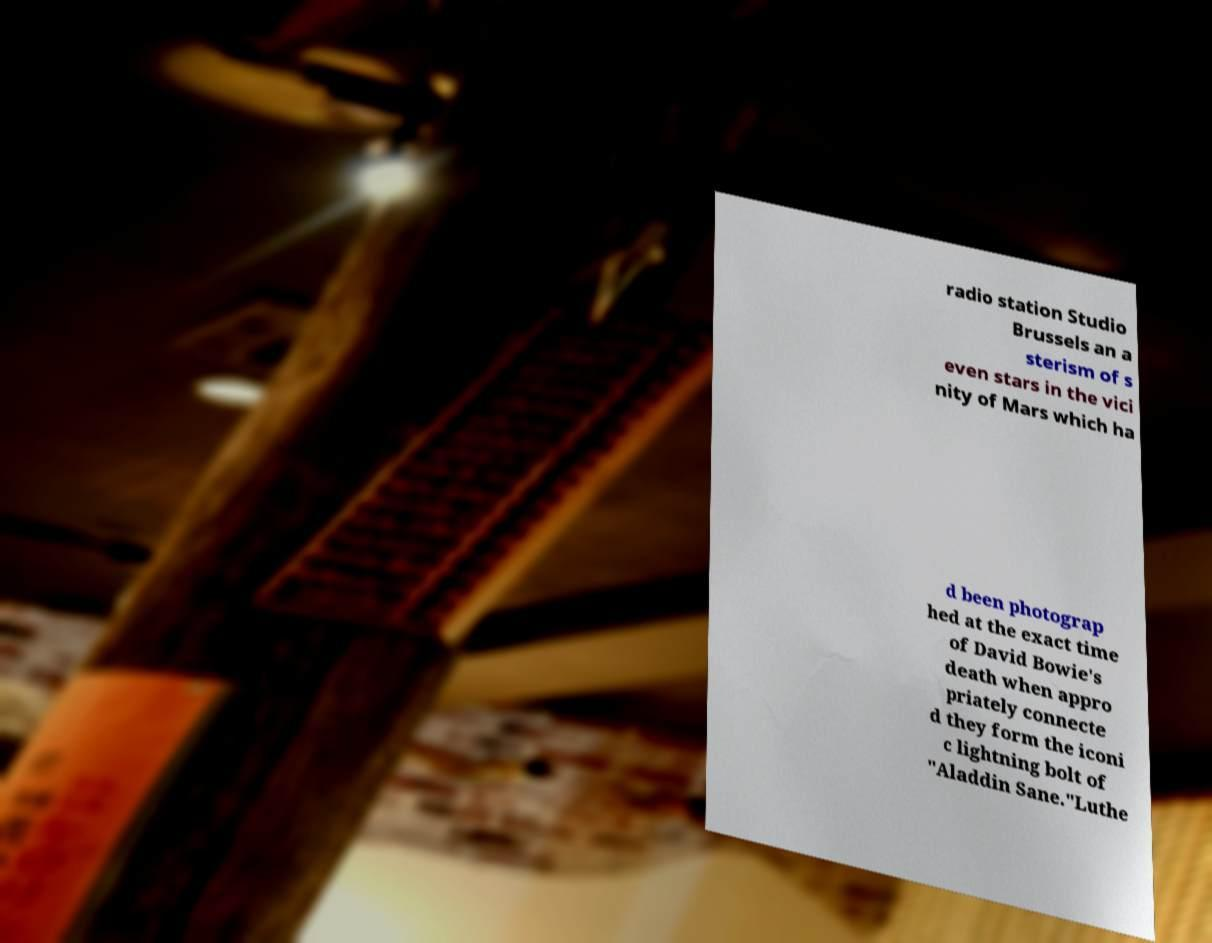Please identify and transcribe the text found in this image. radio station Studio Brussels an a sterism of s even stars in the vici nity of Mars which ha d been photograp hed at the exact time of David Bowie's death when appro priately connecte d they form the iconi c lightning bolt of "Aladdin Sane."Luthe 